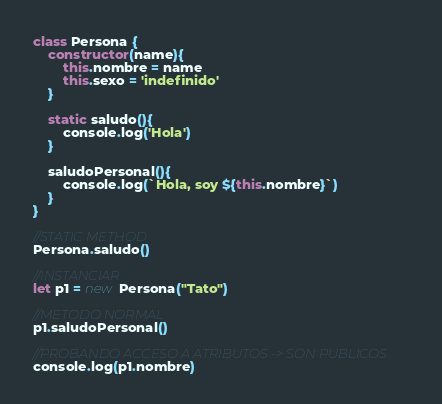Convert code to text. <code><loc_0><loc_0><loc_500><loc_500><_JavaScript_>class Persona {
    constructor(name){
        this.nombre = name
        this.sexo = 'indefinido'
    }   

    static saludo(){
        console.log('Hola')
    }

    saludoPersonal(){
        console.log(`Hola, soy ${this.nombre}`)
    }
}

//STATIC METHOD
Persona.saludo()

//INSTANCIAR
let p1 = new Persona("Tato")

//METODO NORMAL
p1.saludoPersonal()

//PROBANDO ACCESO A ATRIBUTOS -> SON PUBLICOS
console.log(p1.nombre)</code> 